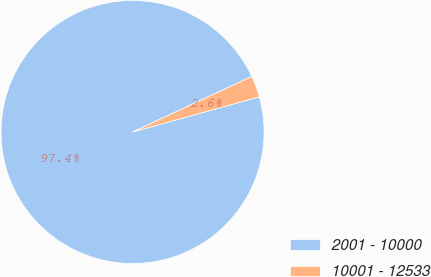Convert chart. <chart><loc_0><loc_0><loc_500><loc_500><pie_chart><fcel>2001 - 10000<fcel>10001 - 12533<nl><fcel>97.37%<fcel>2.63%<nl></chart> 